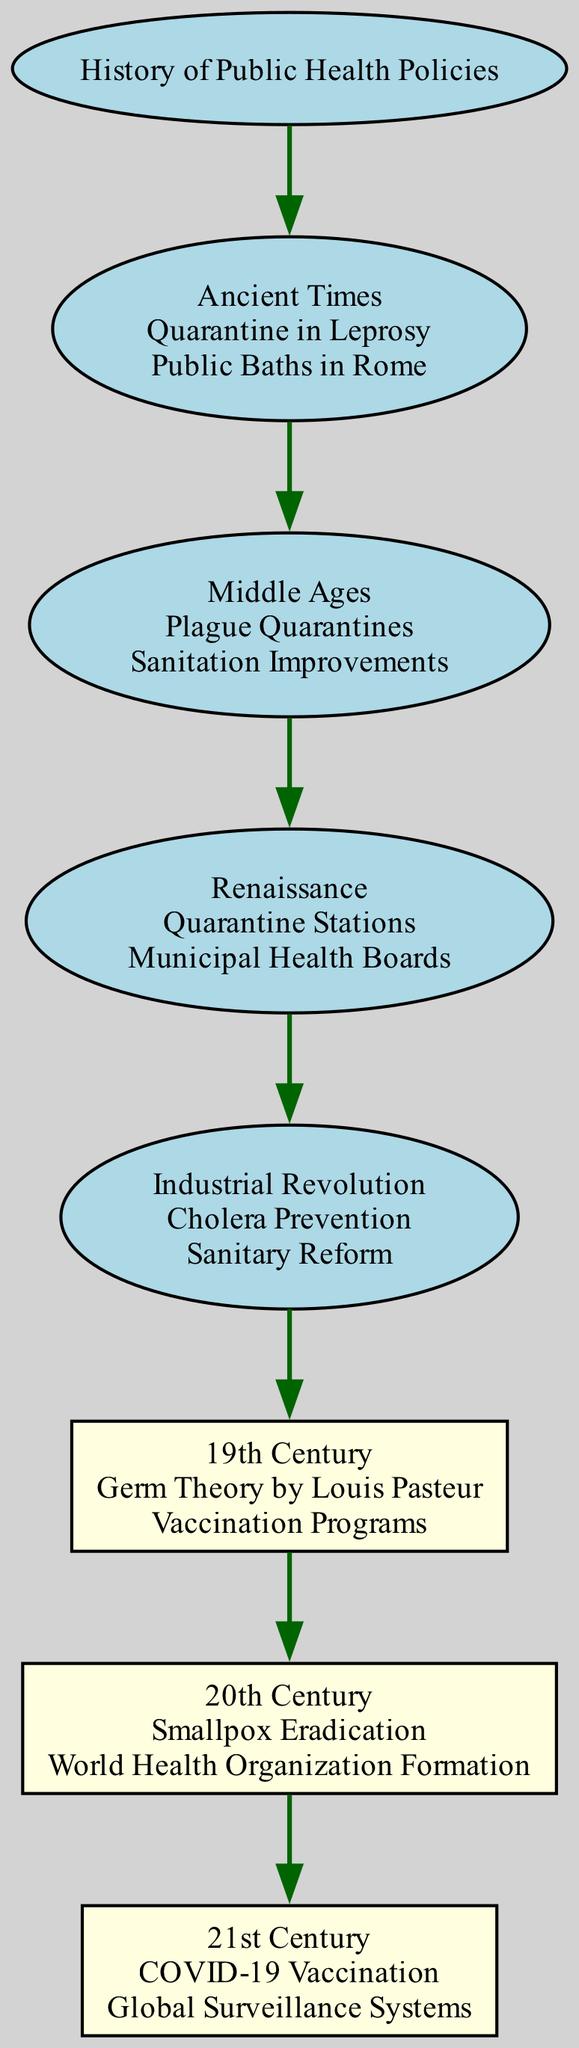What was a key public health policy in Ancient Times? The diagram shows "Quarantine in Leprosy" and "Public Baths in Rome" as key policies during the Ancient Times era. These policies focus on disease containment and hygiene practices. From the diagram, either policy is correct, but "Quarantine in Leprosy" is the first one listed.
Answer: Quarantine in Leprosy How many key policies are listed for the 19th Century? The 19th Century has "Germ Theory by Louis Pasteur" and "Vaccination Programs" as key policies. By counting these, we find a total of two listed policies for this era.
Answer: 2 Which era introduced Vaccination Programs? The diagram shows that Vaccination Programs were a key policy in the 19th Century. Tracing back through the diagram, the 19th Century era is where this policy first appears.
Answer: 19th Century What is the relationship between the Industrial Revolution and the 19th Century? The diagram indicates that the Industrial Revolution is a direct parent of the 19th Century, meaning it precedes and leads into the policies found there. This flow illustrates the timeline of developments in public health policy.
Answer: Parent List any key policies from the 20th Century. The key policies listed for the 20th Century are "Smallpox Eradication" and "World Health Organization Formation." The diagram explicitly names these two policies under this era, confirming their significance in public health history.
Answer: Smallpox Eradication, World Health Organization Formation Which public health policy follows the Renaissance? Inspecting the diagram, the Renaissance era is directly followed by the Industrial Revolution. The key policies associated with this transition include "Cholera Prevention" and "Sanitary Reform." Therefore, analyzing the sequence reveals both the name of the era and the health policies associated with it as subsequent elements.
Answer: Industrial Revolution How many total nodes are there in the diagram? By counting the nodes throughout the diagram, including all eras and key policies, we find a total of seven distinct nodes represented in the diagram. This includes all parent and child relationships depicted.
Answer: 7 Which key policy is associated with COVID-19 in the 21st Century? The policy listed under the 21st Century is "COVID-19 Vaccination." The diagram points this out explicitly, illustrating its importance in the modern public health landscape.
Answer: COVID-19 Vaccination 